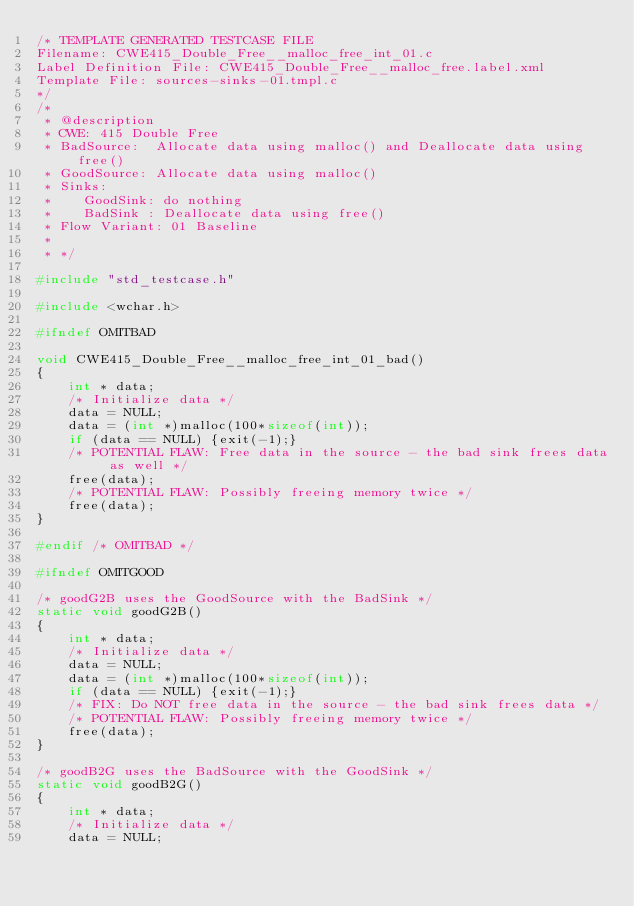<code> <loc_0><loc_0><loc_500><loc_500><_C_>/* TEMPLATE GENERATED TESTCASE FILE
Filename: CWE415_Double_Free__malloc_free_int_01.c
Label Definition File: CWE415_Double_Free__malloc_free.label.xml
Template File: sources-sinks-01.tmpl.c
*/
/*
 * @description
 * CWE: 415 Double Free
 * BadSource:  Allocate data using malloc() and Deallocate data using free()
 * GoodSource: Allocate data using malloc()
 * Sinks:
 *    GoodSink: do nothing
 *    BadSink : Deallocate data using free()
 * Flow Variant: 01 Baseline
 *
 * */

#include "std_testcase.h"

#include <wchar.h>

#ifndef OMITBAD

void CWE415_Double_Free__malloc_free_int_01_bad()
{
    int * data;
    /* Initialize data */
    data = NULL;
    data = (int *)malloc(100*sizeof(int));
    if (data == NULL) {exit(-1);}
    /* POTENTIAL FLAW: Free data in the source - the bad sink frees data as well */
    free(data);
    /* POTENTIAL FLAW: Possibly freeing memory twice */
    free(data);
}

#endif /* OMITBAD */

#ifndef OMITGOOD

/* goodG2B uses the GoodSource with the BadSink */
static void goodG2B()
{
    int * data;
    /* Initialize data */
    data = NULL;
    data = (int *)malloc(100*sizeof(int));
    if (data == NULL) {exit(-1);}
    /* FIX: Do NOT free data in the source - the bad sink frees data */
    /* POTENTIAL FLAW: Possibly freeing memory twice */
    free(data);
}

/* goodB2G uses the BadSource with the GoodSink */
static void goodB2G()
{
    int * data;
    /* Initialize data */
    data = NULL;</code> 